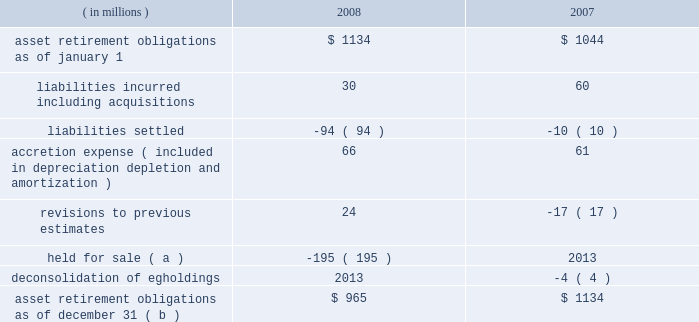Marathon oil corporation notes to consolidated financial statements ( f ) this sale-leaseback financing arrangement relates to a lease of a slab caster at united states steel 2019s fairfield works facility in alabama .
We are the primary obligor under this lease .
Under the financial matters agreement , united states steel has assumed responsibility for all obligations under this lease .
This lease is an amortizing financing with a final maturity of 2012 , subject to additional extensions .
( g ) this obligation relates to a lease of equipment at united states steel 2019s clairton works cokemaking facility in pennsylvania .
We are the primary obligor under this lease .
Under the financial matters agreement , united states steel has assumed responsibility for all obligations under this lease .
This lease is an amortizing financing with a final maturity of 2012 .
( h ) marathon oil canada corporation had an 805 million canadian dollar revolving term credit facility which was secured by substantially all of marathon oil canada corporation 2019s assets and included certain financial covenants , including leverage and interest coverage ratios .
In february 2008 , the outstanding balance was repaid and the facility was terminated .
( i ) these notes are senior secured notes of marathon oil canada corporation .
The notes were secured by substantially all of marathon oil canada corporation 2019s assets .
In january 2008 , we provided a full and unconditional guarantee covering the payment of all principal and interest due under the senior notes .
( j ) these obligations as of december 31 , 2008 include $ 126 million related to assets under construction at that date for which capital leases or sale-leaseback financings will commence upon completion of construction .
The amounts currently reported are based upon the percent of construction completed as of december 31 , 2008 and therefore do not reflect future minimum lease obligations of $ 209 million .
( k ) payments of long-term debt for the years 2009 2013 2013 are $ 99 million , $ 98 million , $ 257 million , $ 1487 million and $ 279 million .
Of these amounts , payments assumed by united states steel are $ 15 million , $ 17 million , $ 161 million , $ 19 million and zero .
( l ) in the event of a change in control , as defined in the related agreements , debt obligations totaling $ 669 million at december 31 , 2008 , may be declared immediately due and payable .
( m ) see note 17 for information on interest rate swaps .
On february 17 , 2009 , we issued $ 700 million aggregate principal amount of senior notes bearing interest at 6.5 percent with a maturity date of february 15 , 2014 and $ 800 million aggregate principal amount of senior notes bearing interest at 7.5 percent with a maturity date of february 15 , 2019 .
Interest on both issues is payable semi- annually beginning august 15 , 2009 .
21 .
Asset retirement obligations the following summarizes the changes in asset retirement obligations : ( in millions ) 2008 2007 .
Asset retirement obligations as of december 31 ( b ) $ 965 $ 1134 ( a ) see note 7 for information related to our assets held for sale .
( b ) includes asset retirement obligation of $ 2 and $ 3 million classified as short-term at december 31 , 2008 , and 2007. .
By how much did asset retirement obligations increase from 2006 to 2007? 
Computations: ((1134 - 1044) / 1044)
Answer: 0.08621. 